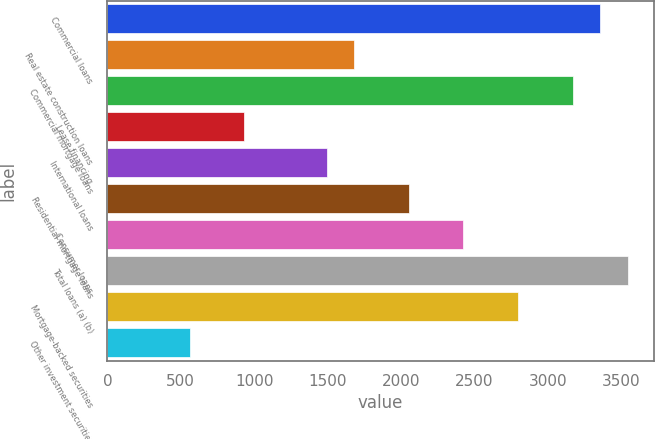<chart> <loc_0><loc_0><loc_500><loc_500><bar_chart><fcel>Commercial loans<fcel>Real estate construction loans<fcel>Commercial mortgage loans<fcel>Lease financing<fcel>International loans<fcel>Residential mortgage loans<fcel>Consumer loans<fcel>Total loans (a) (b)<fcel>Mortgage-backed securities<fcel>Other investment securities<nl><fcel>3358<fcel>1679.5<fcel>3171.5<fcel>933.5<fcel>1493<fcel>2052.5<fcel>2425.5<fcel>3544.5<fcel>2798.5<fcel>560.5<nl></chart> 